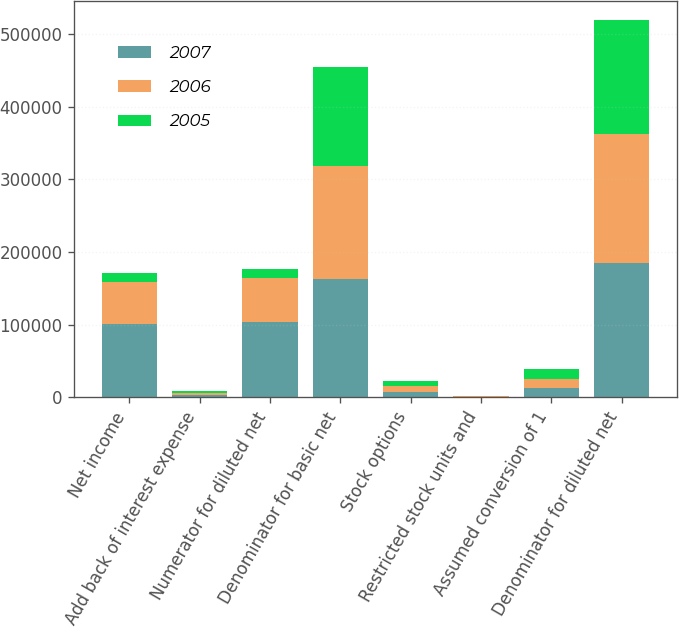<chart> <loc_0><loc_0><loc_500><loc_500><stacked_bar_chart><ecel><fcel>Net income<fcel>Add back of interest expense<fcel>Numerator for diluted net<fcel>Denominator for basic net<fcel>Stock options<fcel>Restricted stock units and<fcel>Assumed conversion of 1<fcel>Denominator for diluted net<nl><fcel>2007<fcel>100967<fcel>2840<fcel>103807<fcel>162959<fcel>7354<fcel>798<fcel>12932<fcel>185094<nl><fcel>2006<fcel>57401<fcel>2841<fcel>60242<fcel>155366<fcel>7704<fcel>752<fcel>12945<fcel>176767<nl><fcel>2005<fcel>12945<fcel>2841<fcel>12945<fcel>136167<fcel>7691<fcel>141<fcel>12945<fcel>156944<nl></chart> 